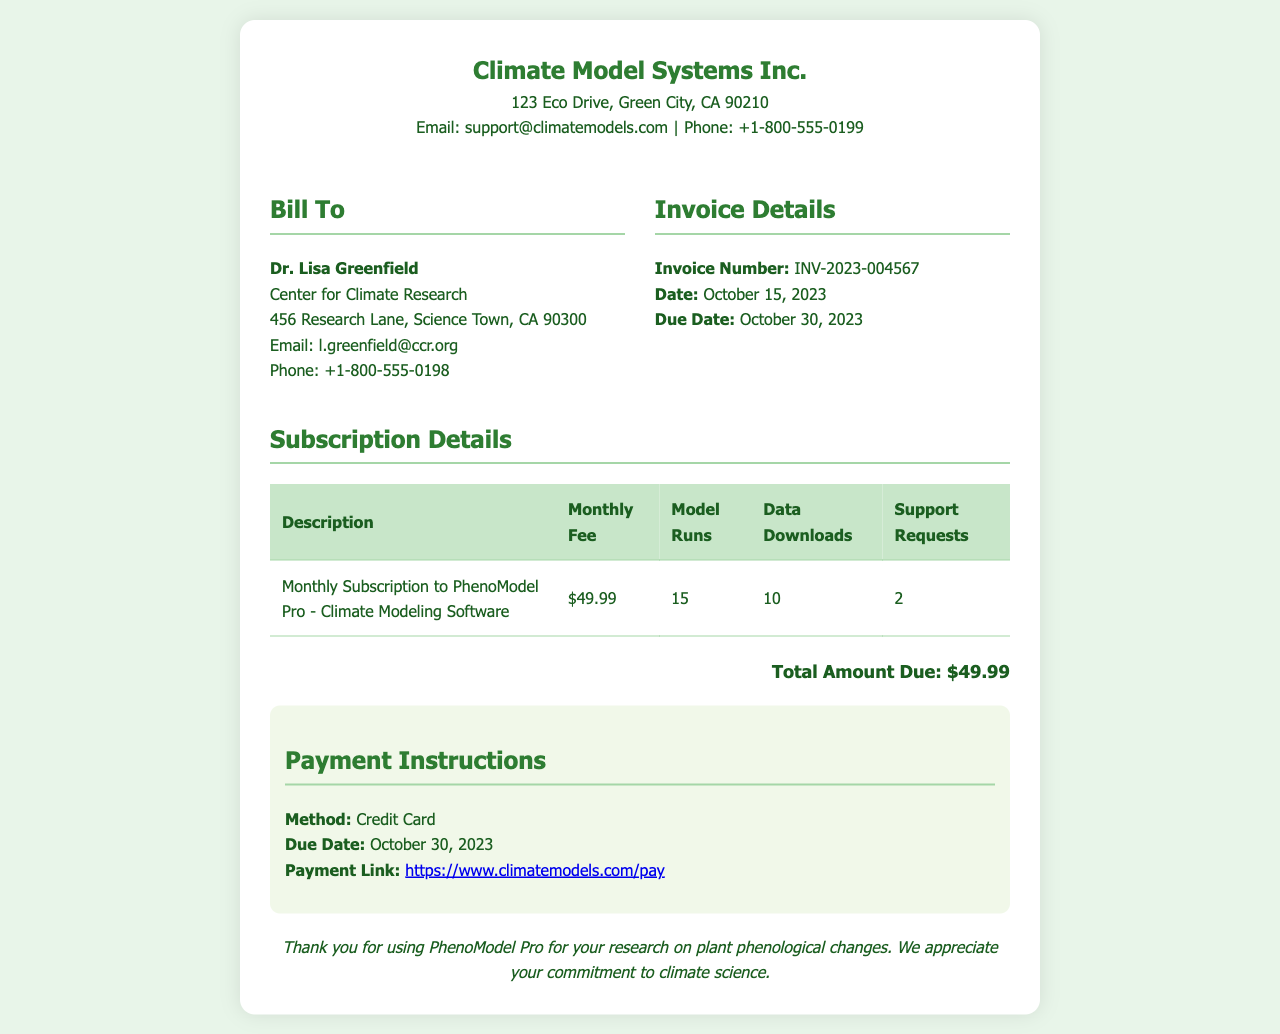What is the name of the company? The company name is found at the top of the invoice.
Answer: Climate Model Systems Inc What is the invoice number? The invoice number is specified under the invoice details section.
Answer: INV-2023-004567 What is the monthly fee for the subscription? The monthly fee is listed in the subscription details table.
Answer: $49.99 When is the due date for this invoice? The due date can be found in the invoice details section.
Answer: October 30, 2023 How many model runs are included in the subscription? The number of model runs is provided in the subscription details table.
Answer: 15 What is the total amount due? The total amount due is clearly stated at the bottom of the invoice.
Answer: $49.99 What payment method is accepted? The accepted payment method is noted in the payment instructions section.
Answer: Credit Card How many data downloads are allowed per month? The number of data downloads is listed in the subscription details table.
Answer: 10 What is the email address of the company? The company's email address is given in the header section.
Answer: support@climatemodels.com 